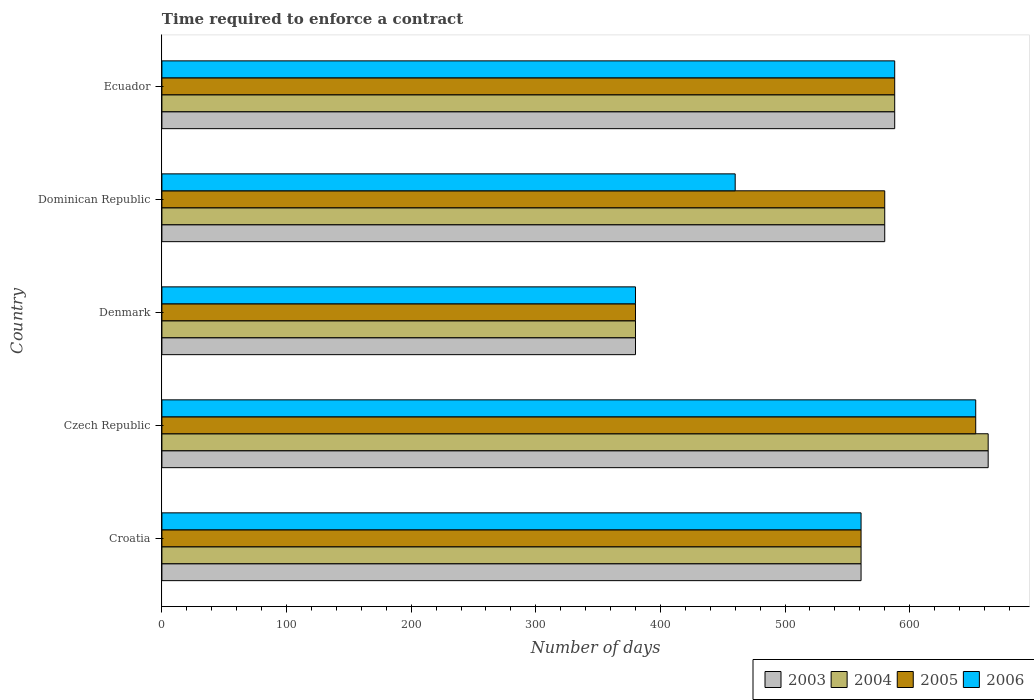How many different coloured bars are there?
Your response must be concise. 4. Are the number of bars per tick equal to the number of legend labels?
Your response must be concise. Yes. How many bars are there on the 4th tick from the top?
Provide a short and direct response. 4. What is the label of the 5th group of bars from the top?
Ensure brevity in your answer.  Croatia. What is the number of days required to enforce a contract in 2005 in Czech Republic?
Offer a very short reply. 653. Across all countries, what is the maximum number of days required to enforce a contract in 2006?
Keep it short and to the point. 653. Across all countries, what is the minimum number of days required to enforce a contract in 2005?
Provide a succinct answer. 380. In which country was the number of days required to enforce a contract in 2005 maximum?
Make the answer very short. Czech Republic. What is the total number of days required to enforce a contract in 2003 in the graph?
Provide a short and direct response. 2772. What is the difference between the number of days required to enforce a contract in 2005 in Denmark and that in Dominican Republic?
Provide a succinct answer. -200. What is the difference between the number of days required to enforce a contract in 2004 in Denmark and the number of days required to enforce a contract in 2003 in Ecuador?
Provide a short and direct response. -208. What is the average number of days required to enforce a contract in 2006 per country?
Make the answer very short. 528.4. What is the difference between the number of days required to enforce a contract in 2004 and number of days required to enforce a contract in 2003 in Denmark?
Provide a succinct answer. 0. In how many countries, is the number of days required to enforce a contract in 2003 greater than 200 days?
Offer a terse response. 5. What is the ratio of the number of days required to enforce a contract in 2003 in Czech Republic to that in Denmark?
Keep it short and to the point. 1.74. What is the difference between the highest and the second highest number of days required to enforce a contract in 2005?
Offer a very short reply. 65. What is the difference between the highest and the lowest number of days required to enforce a contract in 2003?
Provide a short and direct response. 283. In how many countries, is the number of days required to enforce a contract in 2006 greater than the average number of days required to enforce a contract in 2006 taken over all countries?
Offer a terse response. 3. What does the 1st bar from the top in Czech Republic represents?
Offer a terse response. 2006. What does the 2nd bar from the bottom in Czech Republic represents?
Your answer should be very brief. 2004. Does the graph contain any zero values?
Keep it short and to the point. No. What is the title of the graph?
Give a very brief answer. Time required to enforce a contract. What is the label or title of the X-axis?
Offer a very short reply. Number of days. What is the label or title of the Y-axis?
Make the answer very short. Country. What is the Number of days in 2003 in Croatia?
Ensure brevity in your answer.  561. What is the Number of days in 2004 in Croatia?
Ensure brevity in your answer.  561. What is the Number of days in 2005 in Croatia?
Provide a succinct answer. 561. What is the Number of days of 2006 in Croatia?
Give a very brief answer. 561. What is the Number of days of 2003 in Czech Republic?
Keep it short and to the point. 663. What is the Number of days in 2004 in Czech Republic?
Ensure brevity in your answer.  663. What is the Number of days of 2005 in Czech Republic?
Ensure brevity in your answer.  653. What is the Number of days of 2006 in Czech Republic?
Your answer should be compact. 653. What is the Number of days of 2003 in Denmark?
Keep it short and to the point. 380. What is the Number of days of 2004 in Denmark?
Provide a succinct answer. 380. What is the Number of days in 2005 in Denmark?
Offer a terse response. 380. What is the Number of days of 2006 in Denmark?
Your response must be concise. 380. What is the Number of days of 2003 in Dominican Republic?
Make the answer very short. 580. What is the Number of days of 2004 in Dominican Republic?
Offer a very short reply. 580. What is the Number of days in 2005 in Dominican Republic?
Your response must be concise. 580. What is the Number of days of 2006 in Dominican Republic?
Offer a very short reply. 460. What is the Number of days in 2003 in Ecuador?
Make the answer very short. 588. What is the Number of days in 2004 in Ecuador?
Provide a succinct answer. 588. What is the Number of days of 2005 in Ecuador?
Offer a very short reply. 588. What is the Number of days of 2006 in Ecuador?
Your response must be concise. 588. Across all countries, what is the maximum Number of days in 2003?
Provide a succinct answer. 663. Across all countries, what is the maximum Number of days of 2004?
Offer a very short reply. 663. Across all countries, what is the maximum Number of days of 2005?
Offer a terse response. 653. Across all countries, what is the maximum Number of days of 2006?
Make the answer very short. 653. Across all countries, what is the minimum Number of days of 2003?
Your answer should be compact. 380. Across all countries, what is the minimum Number of days of 2004?
Your answer should be compact. 380. Across all countries, what is the minimum Number of days of 2005?
Your response must be concise. 380. Across all countries, what is the minimum Number of days in 2006?
Offer a very short reply. 380. What is the total Number of days of 2003 in the graph?
Give a very brief answer. 2772. What is the total Number of days in 2004 in the graph?
Provide a short and direct response. 2772. What is the total Number of days of 2005 in the graph?
Your answer should be very brief. 2762. What is the total Number of days of 2006 in the graph?
Your answer should be very brief. 2642. What is the difference between the Number of days in 2003 in Croatia and that in Czech Republic?
Give a very brief answer. -102. What is the difference between the Number of days of 2004 in Croatia and that in Czech Republic?
Provide a short and direct response. -102. What is the difference between the Number of days in 2005 in Croatia and that in Czech Republic?
Provide a short and direct response. -92. What is the difference between the Number of days of 2006 in Croatia and that in Czech Republic?
Offer a very short reply. -92. What is the difference between the Number of days of 2003 in Croatia and that in Denmark?
Provide a succinct answer. 181. What is the difference between the Number of days of 2004 in Croatia and that in Denmark?
Ensure brevity in your answer.  181. What is the difference between the Number of days in 2005 in Croatia and that in Denmark?
Give a very brief answer. 181. What is the difference between the Number of days of 2006 in Croatia and that in Denmark?
Your answer should be compact. 181. What is the difference between the Number of days of 2003 in Croatia and that in Dominican Republic?
Your answer should be very brief. -19. What is the difference between the Number of days in 2004 in Croatia and that in Dominican Republic?
Offer a terse response. -19. What is the difference between the Number of days of 2005 in Croatia and that in Dominican Republic?
Your answer should be very brief. -19. What is the difference between the Number of days in 2006 in Croatia and that in Dominican Republic?
Give a very brief answer. 101. What is the difference between the Number of days of 2003 in Croatia and that in Ecuador?
Make the answer very short. -27. What is the difference between the Number of days in 2006 in Croatia and that in Ecuador?
Your response must be concise. -27. What is the difference between the Number of days of 2003 in Czech Republic and that in Denmark?
Provide a short and direct response. 283. What is the difference between the Number of days in 2004 in Czech Republic and that in Denmark?
Provide a short and direct response. 283. What is the difference between the Number of days of 2005 in Czech Republic and that in Denmark?
Your answer should be very brief. 273. What is the difference between the Number of days in 2006 in Czech Republic and that in Denmark?
Make the answer very short. 273. What is the difference between the Number of days of 2005 in Czech Republic and that in Dominican Republic?
Offer a very short reply. 73. What is the difference between the Number of days in 2006 in Czech Republic and that in Dominican Republic?
Keep it short and to the point. 193. What is the difference between the Number of days in 2003 in Czech Republic and that in Ecuador?
Provide a succinct answer. 75. What is the difference between the Number of days in 2004 in Czech Republic and that in Ecuador?
Your answer should be very brief. 75. What is the difference between the Number of days in 2006 in Czech Republic and that in Ecuador?
Keep it short and to the point. 65. What is the difference between the Number of days in 2003 in Denmark and that in Dominican Republic?
Offer a terse response. -200. What is the difference between the Number of days in 2004 in Denmark and that in Dominican Republic?
Ensure brevity in your answer.  -200. What is the difference between the Number of days of 2005 in Denmark and that in Dominican Republic?
Keep it short and to the point. -200. What is the difference between the Number of days in 2006 in Denmark and that in Dominican Republic?
Ensure brevity in your answer.  -80. What is the difference between the Number of days in 2003 in Denmark and that in Ecuador?
Your response must be concise. -208. What is the difference between the Number of days of 2004 in Denmark and that in Ecuador?
Your answer should be compact. -208. What is the difference between the Number of days of 2005 in Denmark and that in Ecuador?
Make the answer very short. -208. What is the difference between the Number of days in 2006 in Denmark and that in Ecuador?
Provide a short and direct response. -208. What is the difference between the Number of days in 2003 in Dominican Republic and that in Ecuador?
Your response must be concise. -8. What is the difference between the Number of days of 2006 in Dominican Republic and that in Ecuador?
Make the answer very short. -128. What is the difference between the Number of days of 2003 in Croatia and the Number of days of 2004 in Czech Republic?
Provide a succinct answer. -102. What is the difference between the Number of days in 2003 in Croatia and the Number of days in 2005 in Czech Republic?
Offer a terse response. -92. What is the difference between the Number of days in 2003 in Croatia and the Number of days in 2006 in Czech Republic?
Provide a short and direct response. -92. What is the difference between the Number of days of 2004 in Croatia and the Number of days of 2005 in Czech Republic?
Give a very brief answer. -92. What is the difference between the Number of days of 2004 in Croatia and the Number of days of 2006 in Czech Republic?
Give a very brief answer. -92. What is the difference between the Number of days in 2005 in Croatia and the Number of days in 2006 in Czech Republic?
Provide a short and direct response. -92. What is the difference between the Number of days of 2003 in Croatia and the Number of days of 2004 in Denmark?
Ensure brevity in your answer.  181. What is the difference between the Number of days in 2003 in Croatia and the Number of days in 2005 in Denmark?
Provide a succinct answer. 181. What is the difference between the Number of days in 2003 in Croatia and the Number of days in 2006 in Denmark?
Keep it short and to the point. 181. What is the difference between the Number of days in 2004 in Croatia and the Number of days in 2005 in Denmark?
Your response must be concise. 181. What is the difference between the Number of days of 2004 in Croatia and the Number of days of 2006 in Denmark?
Ensure brevity in your answer.  181. What is the difference between the Number of days in 2005 in Croatia and the Number of days in 2006 in Denmark?
Your answer should be very brief. 181. What is the difference between the Number of days in 2003 in Croatia and the Number of days in 2004 in Dominican Republic?
Provide a succinct answer. -19. What is the difference between the Number of days of 2003 in Croatia and the Number of days of 2005 in Dominican Republic?
Provide a short and direct response. -19. What is the difference between the Number of days of 2003 in Croatia and the Number of days of 2006 in Dominican Republic?
Your answer should be compact. 101. What is the difference between the Number of days in 2004 in Croatia and the Number of days in 2006 in Dominican Republic?
Offer a terse response. 101. What is the difference between the Number of days of 2005 in Croatia and the Number of days of 2006 in Dominican Republic?
Ensure brevity in your answer.  101. What is the difference between the Number of days in 2003 in Croatia and the Number of days in 2004 in Ecuador?
Your answer should be very brief. -27. What is the difference between the Number of days of 2003 in Croatia and the Number of days of 2005 in Ecuador?
Make the answer very short. -27. What is the difference between the Number of days in 2003 in Croatia and the Number of days in 2006 in Ecuador?
Provide a short and direct response. -27. What is the difference between the Number of days in 2005 in Croatia and the Number of days in 2006 in Ecuador?
Keep it short and to the point. -27. What is the difference between the Number of days of 2003 in Czech Republic and the Number of days of 2004 in Denmark?
Your answer should be very brief. 283. What is the difference between the Number of days in 2003 in Czech Republic and the Number of days in 2005 in Denmark?
Give a very brief answer. 283. What is the difference between the Number of days in 2003 in Czech Republic and the Number of days in 2006 in Denmark?
Offer a terse response. 283. What is the difference between the Number of days in 2004 in Czech Republic and the Number of days in 2005 in Denmark?
Your answer should be compact. 283. What is the difference between the Number of days in 2004 in Czech Republic and the Number of days in 2006 in Denmark?
Your response must be concise. 283. What is the difference between the Number of days of 2005 in Czech Republic and the Number of days of 2006 in Denmark?
Provide a succinct answer. 273. What is the difference between the Number of days of 2003 in Czech Republic and the Number of days of 2004 in Dominican Republic?
Make the answer very short. 83. What is the difference between the Number of days of 2003 in Czech Republic and the Number of days of 2006 in Dominican Republic?
Provide a succinct answer. 203. What is the difference between the Number of days in 2004 in Czech Republic and the Number of days in 2005 in Dominican Republic?
Your answer should be compact. 83. What is the difference between the Number of days in 2004 in Czech Republic and the Number of days in 2006 in Dominican Republic?
Offer a terse response. 203. What is the difference between the Number of days in 2005 in Czech Republic and the Number of days in 2006 in Dominican Republic?
Offer a terse response. 193. What is the difference between the Number of days in 2003 in Czech Republic and the Number of days in 2004 in Ecuador?
Make the answer very short. 75. What is the difference between the Number of days of 2003 in Denmark and the Number of days of 2004 in Dominican Republic?
Your answer should be compact. -200. What is the difference between the Number of days in 2003 in Denmark and the Number of days in 2005 in Dominican Republic?
Keep it short and to the point. -200. What is the difference between the Number of days of 2003 in Denmark and the Number of days of 2006 in Dominican Republic?
Keep it short and to the point. -80. What is the difference between the Number of days of 2004 in Denmark and the Number of days of 2005 in Dominican Republic?
Make the answer very short. -200. What is the difference between the Number of days in 2004 in Denmark and the Number of days in 2006 in Dominican Republic?
Offer a very short reply. -80. What is the difference between the Number of days of 2005 in Denmark and the Number of days of 2006 in Dominican Republic?
Your answer should be very brief. -80. What is the difference between the Number of days in 2003 in Denmark and the Number of days in 2004 in Ecuador?
Offer a very short reply. -208. What is the difference between the Number of days in 2003 in Denmark and the Number of days in 2005 in Ecuador?
Offer a very short reply. -208. What is the difference between the Number of days in 2003 in Denmark and the Number of days in 2006 in Ecuador?
Make the answer very short. -208. What is the difference between the Number of days of 2004 in Denmark and the Number of days of 2005 in Ecuador?
Ensure brevity in your answer.  -208. What is the difference between the Number of days of 2004 in Denmark and the Number of days of 2006 in Ecuador?
Offer a very short reply. -208. What is the difference between the Number of days of 2005 in Denmark and the Number of days of 2006 in Ecuador?
Provide a short and direct response. -208. What is the difference between the Number of days of 2003 in Dominican Republic and the Number of days of 2004 in Ecuador?
Give a very brief answer. -8. What is the difference between the Number of days in 2003 in Dominican Republic and the Number of days in 2006 in Ecuador?
Your answer should be very brief. -8. What is the difference between the Number of days in 2004 in Dominican Republic and the Number of days in 2005 in Ecuador?
Keep it short and to the point. -8. What is the average Number of days in 2003 per country?
Your answer should be very brief. 554.4. What is the average Number of days in 2004 per country?
Your answer should be very brief. 554.4. What is the average Number of days in 2005 per country?
Your answer should be very brief. 552.4. What is the average Number of days in 2006 per country?
Your response must be concise. 528.4. What is the difference between the Number of days in 2003 and Number of days in 2004 in Croatia?
Ensure brevity in your answer.  0. What is the difference between the Number of days in 2003 and Number of days in 2005 in Croatia?
Ensure brevity in your answer.  0. What is the difference between the Number of days in 2004 and Number of days in 2005 in Croatia?
Provide a succinct answer. 0. What is the difference between the Number of days of 2004 and Number of days of 2006 in Croatia?
Offer a very short reply. 0. What is the difference between the Number of days of 2003 and Number of days of 2004 in Czech Republic?
Ensure brevity in your answer.  0. What is the difference between the Number of days of 2003 and Number of days of 2006 in Czech Republic?
Offer a terse response. 10. What is the difference between the Number of days in 2004 and Number of days in 2005 in Czech Republic?
Keep it short and to the point. 10. What is the difference between the Number of days in 2004 and Number of days in 2006 in Czech Republic?
Give a very brief answer. 10. What is the difference between the Number of days in 2005 and Number of days in 2006 in Czech Republic?
Offer a terse response. 0. What is the difference between the Number of days in 2003 and Number of days in 2006 in Denmark?
Provide a short and direct response. 0. What is the difference between the Number of days of 2003 and Number of days of 2006 in Dominican Republic?
Provide a short and direct response. 120. What is the difference between the Number of days in 2004 and Number of days in 2006 in Dominican Republic?
Offer a terse response. 120. What is the difference between the Number of days in 2005 and Number of days in 2006 in Dominican Republic?
Provide a short and direct response. 120. What is the difference between the Number of days of 2003 and Number of days of 2005 in Ecuador?
Give a very brief answer. 0. What is the difference between the Number of days of 2004 and Number of days of 2006 in Ecuador?
Make the answer very short. 0. What is the ratio of the Number of days in 2003 in Croatia to that in Czech Republic?
Provide a succinct answer. 0.85. What is the ratio of the Number of days of 2004 in Croatia to that in Czech Republic?
Make the answer very short. 0.85. What is the ratio of the Number of days in 2005 in Croatia to that in Czech Republic?
Provide a succinct answer. 0.86. What is the ratio of the Number of days of 2006 in Croatia to that in Czech Republic?
Make the answer very short. 0.86. What is the ratio of the Number of days of 2003 in Croatia to that in Denmark?
Provide a short and direct response. 1.48. What is the ratio of the Number of days in 2004 in Croatia to that in Denmark?
Your answer should be very brief. 1.48. What is the ratio of the Number of days in 2005 in Croatia to that in Denmark?
Keep it short and to the point. 1.48. What is the ratio of the Number of days of 2006 in Croatia to that in Denmark?
Keep it short and to the point. 1.48. What is the ratio of the Number of days of 2003 in Croatia to that in Dominican Republic?
Provide a succinct answer. 0.97. What is the ratio of the Number of days of 2004 in Croatia to that in Dominican Republic?
Make the answer very short. 0.97. What is the ratio of the Number of days in 2005 in Croatia to that in Dominican Republic?
Your response must be concise. 0.97. What is the ratio of the Number of days in 2006 in Croatia to that in Dominican Republic?
Ensure brevity in your answer.  1.22. What is the ratio of the Number of days in 2003 in Croatia to that in Ecuador?
Your response must be concise. 0.95. What is the ratio of the Number of days in 2004 in Croatia to that in Ecuador?
Offer a very short reply. 0.95. What is the ratio of the Number of days of 2005 in Croatia to that in Ecuador?
Provide a succinct answer. 0.95. What is the ratio of the Number of days of 2006 in Croatia to that in Ecuador?
Provide a succinct answer. 0.95. What is the ratio of the Number of days of 2003 in Czech Republic to that in Denmark?
Provide a short and direct response. 1.74. What is the ratio of the Number of days of 2004 in Czech Republic to that in Denmark?
Offer a terse response. 1.74. What is the ratio of the Number of days of 2005 in Czech Republic to that in Denmark?
Ensure brevity in your answer.  1.72. What is the ratio of the Number of days of 2006 in Czech Republic to that in Denmark?
Offer a terse response. 1.72. What is the ratio of the Number of days of 2003 in Czech Republic to that in Dominican Republic?
Provide a succinct answer. 1.14. What is the ratio of the Number of days of 2004 in Czech Republic to that in Dominican Republic?
Keep it short and to the point. 1.14. What is the ratio of the Number of days of 2005 in Czech Republic to that in Dominican Republic?
Provide a succinct answer. 1.13. What is the ratio of the Number of days in 2006 in Czech Republic to that in Dominican Republic?
Give a very brief answer. 1.42. What is the ratio of the Number of days in 2003 in Czech Republic to that in Ecuador?
Your answer should be compact. 1.13. What is the ratio of the Number of days in 2004 in Czech Republic to that in Ecuador?
Your response must be concise. 1.13. What is the ratio of the Number of days in 2005 in Czech Republic to that in Ecuador?
Offer a terse response. 1.11. What is the ratio of the Number of days in 2006 in Czech Republic to that in Ecuador?
Your answer should be very brief. 1.11. What is the ratio of the Number of days of 2003 in Denmark to that in Dominican Republic?
Provide a succinct answer. 0.66. What is the ratio of the Number of days in 2004 in Denmark to that in Dominican Republic?
Ensure brevity in your answer.  0.66. What is the ratio of the Number of days in 2005 in Denmark to that in Dominican Republic?
Offer a very short reply. 0.66. What is the ratio of the Number of days of 2006 in Denmark to that in Dominican Republic?
Keep it short and to the point. 0.83. What is the ratio of the Number of days of 2003 in Denmark to that in Ecuador?
Your answer should be compact. 0.65. What is the ratio of the Number of days of 2004 in Denmark to that in Ecuador?
Your answer should be compact. 0.65. What is the ratio of the Number of days in 2005 in Denmark to that in Ecuador?
Offer a very short reply. 0.65. What is the ratio of the Number of days of 2006 in Denmark to that in Ecuador?
Ensure brevity in your answer.  0.65. What is the ratio of the Number of days in 2003 in Dominican Republic to that in Ecuador?
Your answer should be very brief. 0.99. What is the ratio of the Number of days of 2004 in Dominican Republic to that in Ecuador?
Your answer should be compact. 0.99. What is the ratio of the Number of days in 2005 in Dominican Republic to that in Ecuador?
Make the answer very short. 0.99. What is the ratio of the Number of days of 2006 in Dominican Republic to that in Ecuador?
Your answer should be very brief. 0.78. What is the difference between the highest and the second highest Number of days of 2006?
Your response must be concise. 65. What is the difference between the highest and the lowest Number of days of 2003?
Ensure brevity in your answer.  283. What is the difference between the highest and the lowest Number of days of 2004?
Make the answer very short. 283. What is the difference between the highest and the lowest Number of days of 2005?
Your response must be concise. 273. What is the difference between the highest and the lowest Number of days in 2006?
Give a very brief answer. 273. 